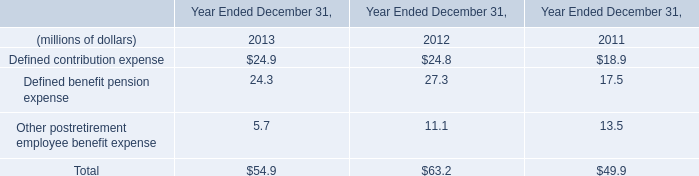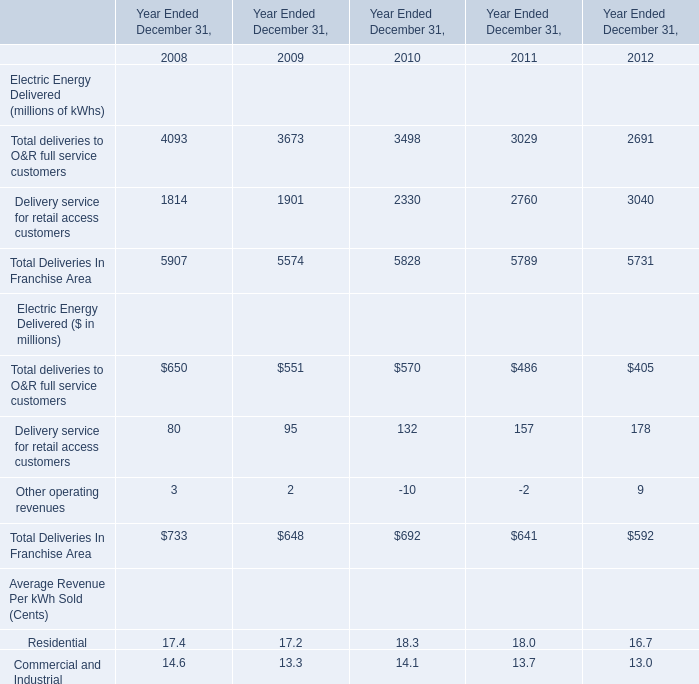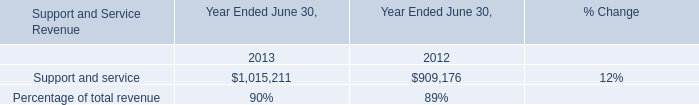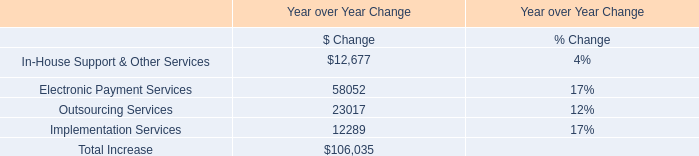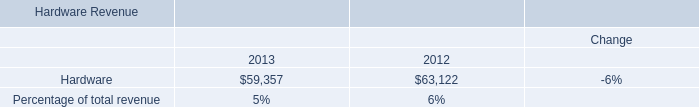What is the sum of Hardware of data 1 2012, Support and service of Year Ended June 30, 2012, and Delivery service for retail access customers of Year Ended December 31, 2009 ? 
Computations: ((63122.0 + 909176.0) + 1901.0)
Answer: 974199.0. 